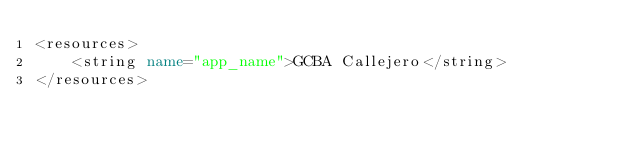Convert code to text. <code><loc_0><loc_0><loc_500><loc_500><_XML_><resources>
    <string name="app_name">GCBA Callejero</string>
</resources>
</code> 